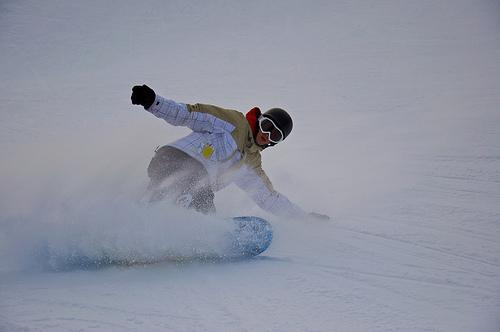Question: what is this person doing?
Choices:
A. Running.
B. Snowboarding.
C. Walking.
D. Riding a snowmobile.
Answer with the letter. Answer: B Question: what is this person wearing on his head?
Choices:
A. A hat.
B. Sunglasses.
C. A helmet.
D. A mask.
Answer with the letter. Answer: C Question: what is he snowboarding on?
Choices:
A. A snowboard.
B. Snow.
C. A halfpipe.
D. The ground.
Answer with the letter. Answer: B Question: how many snowboards is he using?
Choices:
A. 3.
B. 2.
C. 1.
D. 0.
Answer with the letter. Answer: C 